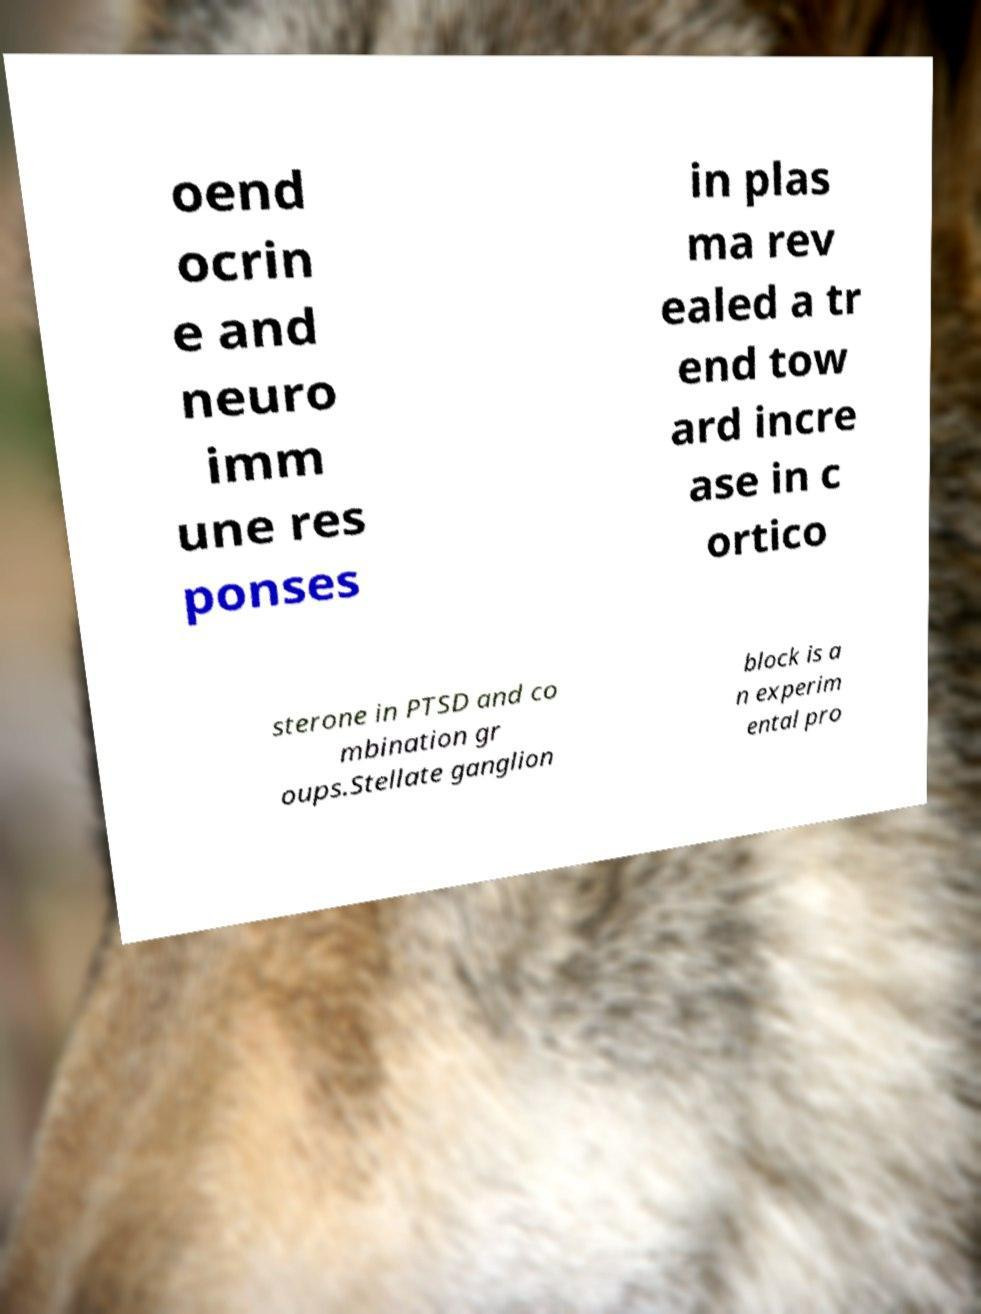Please read and relay the text visible in this image. What does it say? oend ocrin e and neuro imm une res ponses in plas ma rev ealed a tr end tow ard incre ase in c ortico sterone in PTSD and co mbination gr oups.Stellate ganglion block is a n experim ental pro 